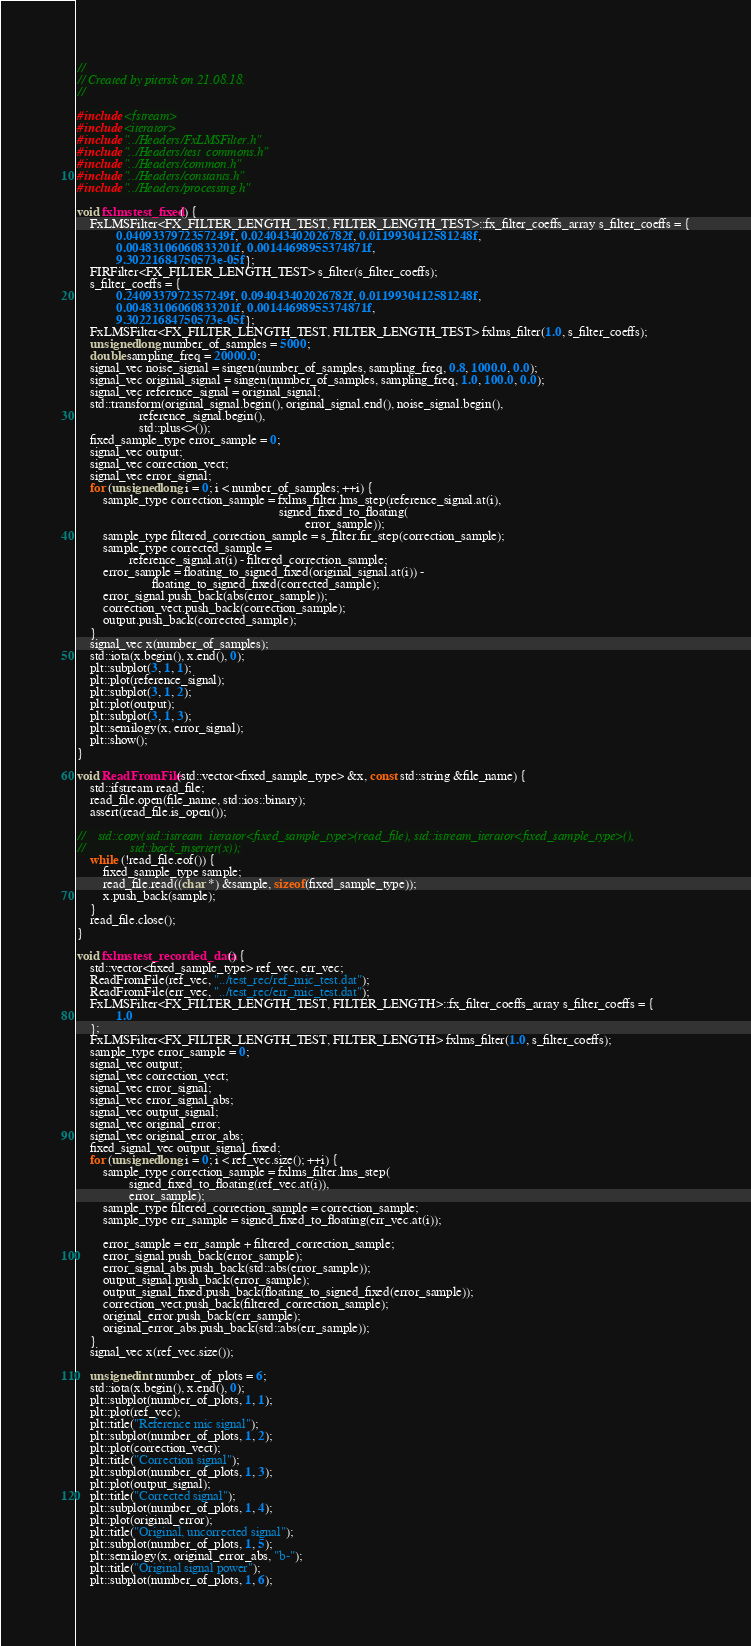Convert code to text. <code><loc_0><loc_0><loc_500><loc_500><_C++_>//
// Created by pitersk on 21.08.18.
//

#include <fstream>
#include <iterator>
#include "../Headers/FxLMSFilter.h"
#include "../Headers/test_commons.h"
#include "../Headers/common.h"
#include "../Headers/constants.h"
#include "../Headers/processing.h"

void fxlmstest_fixed() {
    FxLMSFilter<FX_FILTER_LENGTH_TEST, FILTER_LENGTH_TEST>::fx_filter_coeffs_array s_filter_coeffs = {
            0.0409337972357249f, 0.024043402026782f, 0.0119930412581248f,
            0.00483106060833201f, 0.00144698955374871f,
            9.30221684750573e-05f};
    FIRFilter<FX_FILTER_LENGTH_TEST> s_filter(s_filter_coeffs);
    s_filter_coeffs = {
            0.2409337972357249f, 0.094043402026782f, 0.0119930412581248f,
            0.00483106060833201f, 0.00144698955374871f,
            9.30221684750573e-05f};
    FxLMSFilter<FX_FILTER_LENGTH_TEST, FILTER_LENGTH_TEST> fxlms_filter(1.0, s_filter_coeffs);
    unsigned long number_of_samples = 5000;
    double sampling_freq = 20000.0;
    signal_vec noise_signal = singen(number_of_samples, sampling_freq, 0.8, 1000.0, 0.0);
    signal_vec original_signal = singen(number_of_samples, sampling_freq, 1.0, 100.0, 0.0);
    signal_vec reference_signal = original_signal;
    std::transform(original_signal.begin(), original_signal.end(), noise_signal.begin(),
                   reference_signal.begin(),
                   std::plus<>());
    fixed_sample_type error_sample = 0;
    signal_vec output;
    signal_vec correction_vect;
    signal_vec error_signal;
    for (unsigned long i = 0; i < number_of_samples; ++i) {
        sample_type correction_sample = fxlms_filter.lms_step(reference_signal.at(i),
                                                              signed_fixed_to_floating(
                                                                      error_sample));
        sample_type filtered_correction_sample = s_filter.fir_step(correction_sample);
        sample_type corrected_sample =
                reference_signal.at(i) - filtered_correction_sample;
        error_sample = floating_to_signed_fixed(original_signal.at(i)) -
                       floating_to_signed_fixed(corrected_sample);
        error_signal.push_back(abs(error_sample));
        correction_vect.push_back(correction_sample);
        output.push_back(corrected_sample);
    }
    signal_vec x(number_of_samples);
    std::iota(x.begin(), x.end(), 0);
    plt::subplot(3, 1, 1);
    plt::plot(reference_signal);
    plt::subplot(3, 1, 2);
    plt::plot(output);
    plt::subplot(3, 1, 3);
    plt::semilogy(x, error_signal);
    plt::show();
}

void ReadFromFile(std::vector<fixed_sample_type> &x, const std::string &file_name) {
    std::ifstream read_file;
    read_file.open(file_name, std::ios::binary);
    assert(read_file.is_open());

//    std::copy(std::istream_iterator<fixed_sample_type>(read_file), std::istream_iterator<fixed_sample_type>(),
//              std::back_inserter(x));
    while (!read_file.eof()) {
        fixed_sample_type sample;
        read_file.read((char *) &sample, sizeof(fixed_sample_type));
        x.push_back(sample);
    }
    read_file.close();
}

void fxlmstest_recorded_data() {
    std::vector<fixed_sample_type> ref_vec, err_vec;
    ReadFromFile(ref_vec, "../test_rec/ref_mic_test.dat");
    ReadFromFile(err_vec, "../test_rec/err_mic_test.dat");
    FxLMSFilter<FX_FILTER_LENGTH_TEST, FILTER_LENGTH>::fx_filter_coeffs_array s_filter_coeffs = {
            1.0
    };
    FxLMSFilter<FX_FILTER_LENGTH_TEST, FILTER_LENGTH> fxlms_filter(1.0, s_filter_coeffs);
    sample_type error_sample = 0;
    signal_vec output;
    signal_vec correction_vect;
    signal_vec error_signal;
    signal_vec error_signal_abs;
    signal_vec output_signal;
    signal_vec original_error;
    signal_vec original_error_abs;
    fixed_signal_vec output_signal_fixed;
    for (unsigned long i = 0; i < ref_vec.size(); ++i) {
        sample_type correction_sample = fxlms_filter.lms_step(
                signed_fixed_to_floating(ref_vec.at(i)),
                error_sample);
        sample_type filtered_correction_sample = correction_sample;
        sample_type err_sample = signed_fixed_to_floating(err_vec.at(i));

        error_sample = err_sample + filtered_correction_sample;
        error_signal.push_back(error_sample);
        error_signal_abs.push_back(std::abs(error_sample));
        output_signal.push_back(error_sample);
        output_signal_fixed.push_back(floating_to_signed_fixed(error_sample));
        correction_vect.push_back(filtered_correction_sample);
        original_error.push_back(err_sample);
        original_error_abs.push_back(std::abs(err_sample));
    }
    signal_vec x(ref_vec.size());

    unsigned int number_of_plots = 6;
    std::iota(x.begin(), x.end(), 0);
    plt::subplot(number_of_plots, 1, 1);
    plt::plot(ref_vec);
    plt::title("Reference mic signal");
    plt::subplot(number_of_plots, 1, 2);
    plt::plot(correction_vect);
    plt::title("Correction signal");
    plt::subplot(number_of_plots, 1, 3);
    plt::plot(output_signal);
    plt::title("Corrected signal");
    plt::subplot(number_of_plots, 1, 4);
    plt::plot(original_error);
    plt::title("Original, uncorrected signal");
    plt::subplot(number_of_plots, 1, 5);
    plt::semilogy(x, original_error_abs, "b-");
    plt::title("Original signal power");
    plt::subplot(number_of_plots, 1, 6);</code> 